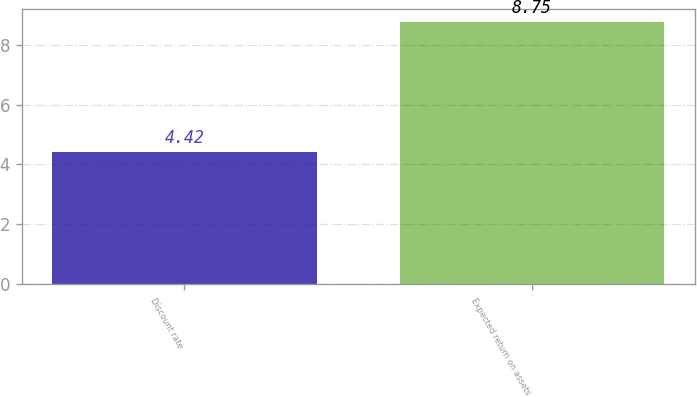Convert chart. <chart><loc_0><loc_0><loc_500><loc_500><bar_chart><fcel>Discount rate<fcel>Expected return on assets<nl><fcel>4.42<fcel>8.75<nl></chart> 